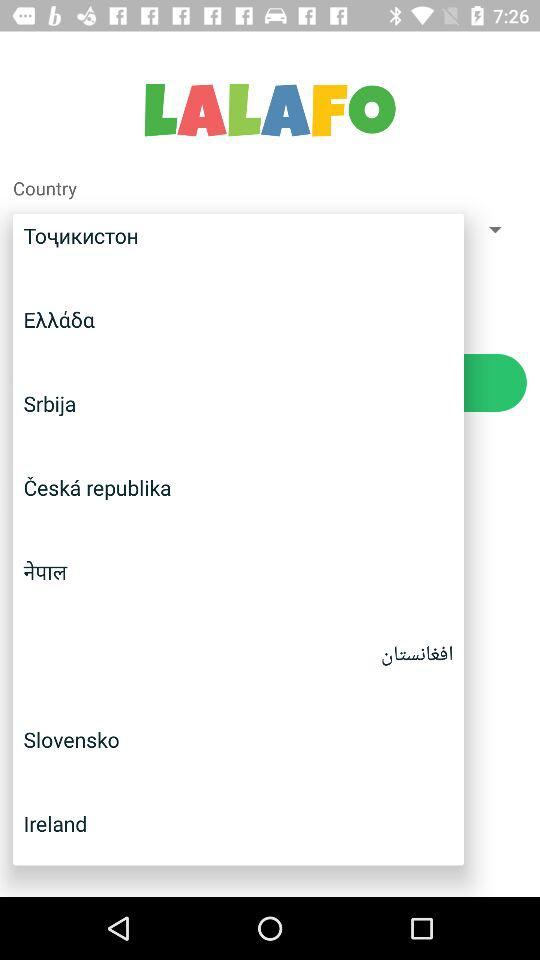What is the application name? The application name is "LALAFO". 